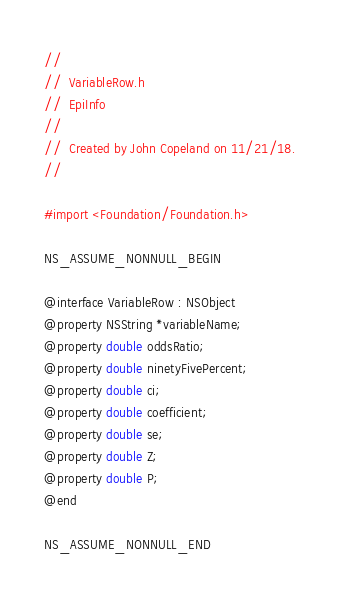<code> <loc_0><loc_0><loc_500><loc_500><_C_>//
//  VariableRow.h
//  EpiInfo
//
//  Created by John Copeland on 11/21/18.
//

#import <Foundation/Foundation.h>

NS_ASSUME_NONNULL_BEGIN

@interface VariableRow : NSObject
@property NSString *variableName;
@property double oddsRatio;
@property double ninetyFivePercent;
@property double ci;
@property double coefficient;
@property double se;
@property double Z;
@property double P;
@end

NS_ASSUME_NONNULL_END
</code> 